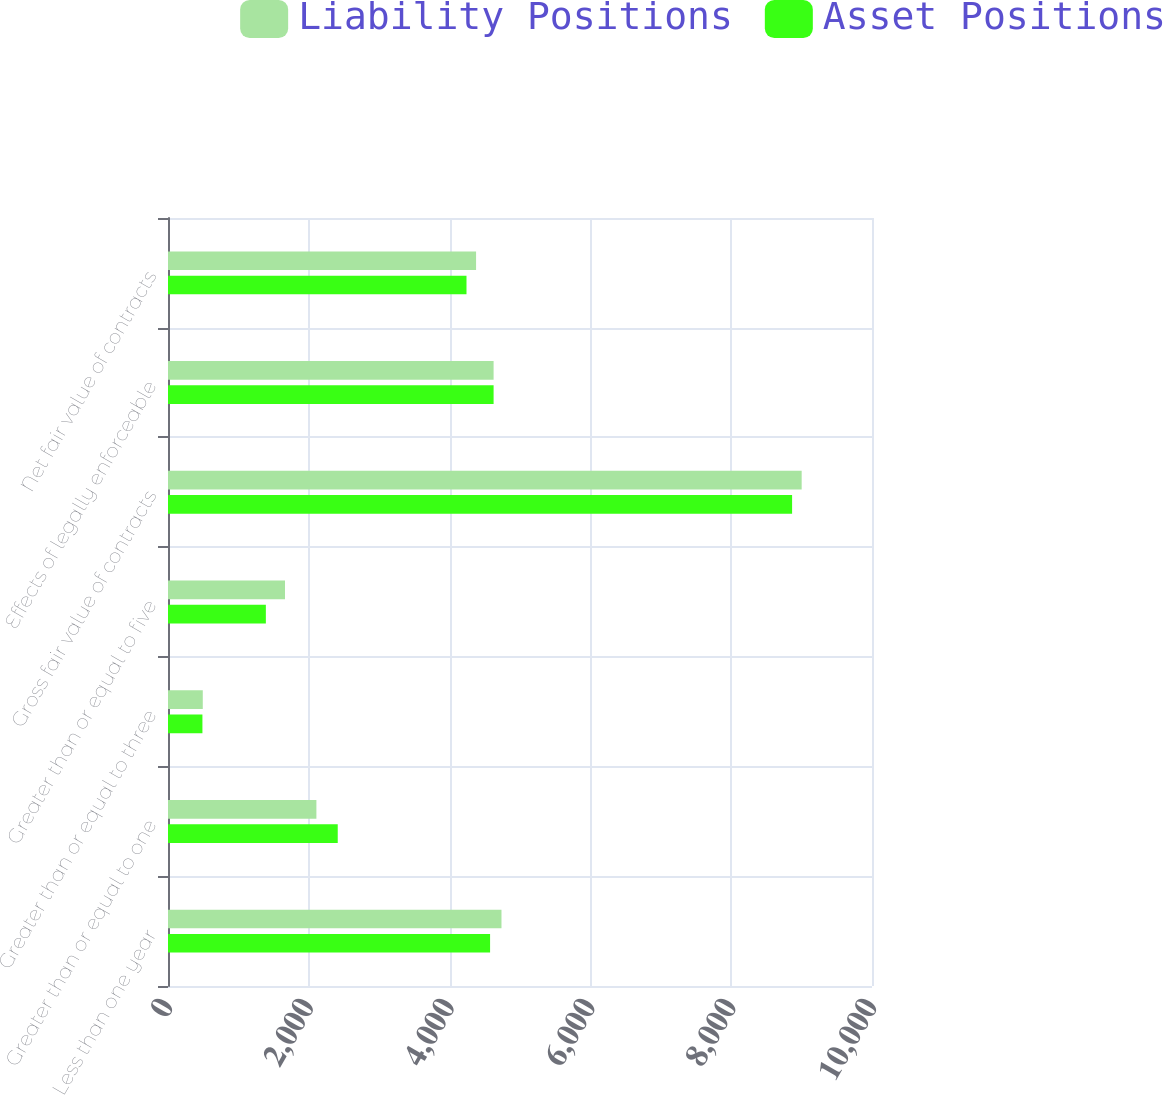<chart> <loc_0><loc_0><loc_500><loc_500><stacked_bar_chart><ecel><fcel>Less than one year<fcel>Greater than or equal to one<fcel>Greater than or equal to three<fcel>Greater than or equal to five<fcel>Gross fair value of contracts<fcel>Effects of legally enforceable<fcel>Net fair value of contracts<nl><fcel>Liability Positions<fcel>4737<fcel>2108<fcel>494<fcel>1662<fcel>9001<fcel>4625<fcel>4376<nl><fcel>Asset Positions<fcel>4575<fcel>2411<fcel>489<fcel>1390<fcel>8865<fcel>4625<fcel>4240<nl></chart> 